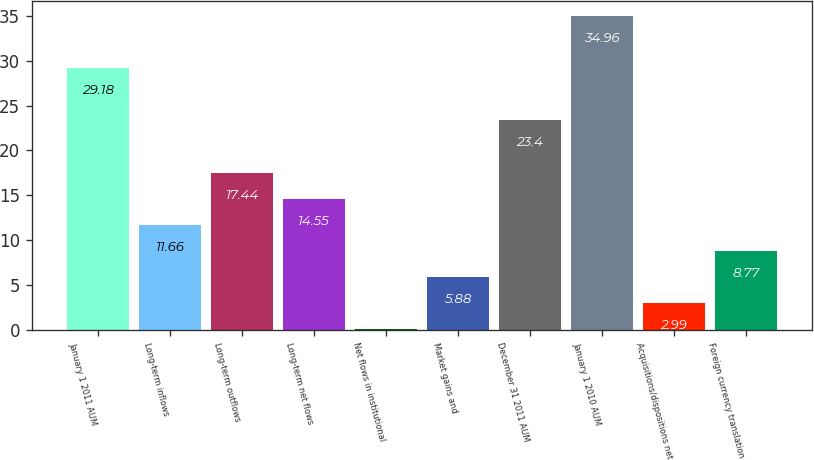Convert chart. <chart><loc_0><loc_0><loc_500><loc_500><bar_chart><fcel>January 1 2011 AUM<fcel>Long-term inflows<fcel>Long-term outflows<fcel>Long-term net flows<fcel>Net flows in institutional<fcel>Market gains and<fcel>December 31 2011 AUM<fcel>January 1 2010 AUM<fcel>Acquisitions/dispositions net<fcel>Foreign currency translation<nl><fcel>29.18<fcel>11.66<fcel>17.44<fcel>14.55<fcel>0.1<fcel>5.88<fcel>23.4<fcel>34.96<fcel>2.99<fcel>8.77<nl></chart> 